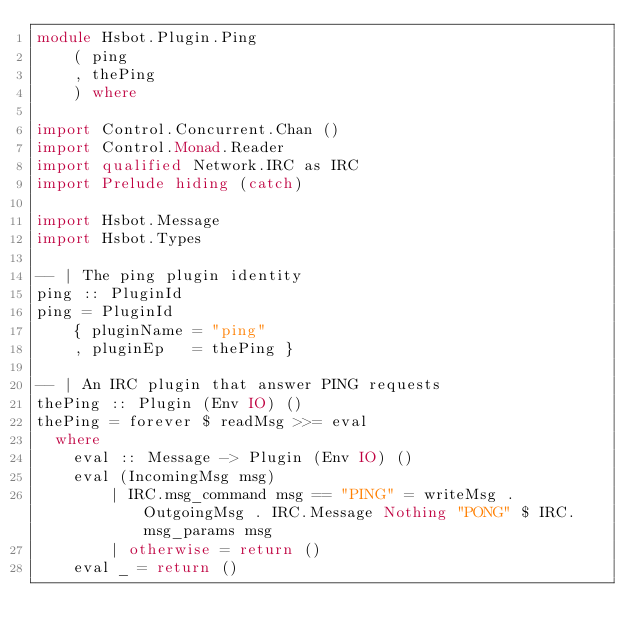Convert code to text. <code><loc_0><loc_0><loc_500><loc_500><_Haskell_>module Hsbot.Plugin.Ping
    ( ping
    , thePing
    ) where

import Control.Concurrent.Chan ()
import Control.Monad.Reader
import qualified Network.IRC as IRC
import Prelude hiding (catch)

import Hsbot.Message
import Hsbot.Types

-- | The ping plugin identity
ping :: PluginId
ping = PluginId
    { pluginName = "ping"
    , pluginEp   = thePing }

-- | An IRC plugin that answer PING requests
thePing :: Plugin (Env IO) ()
thePing = forever $ readMsg >>= eval
  where
    eval :: Message -> Plugin (Env IO) ()
    eval (IncomingMsg msg)
        | IRC.msg_command msg == "PING" = writeMsg . OutgoingMsg . IRC.Message Nothing "PONG" $ IRC.msg_params msg
        | otherwise = return ()
    eval _ = return ()

</code> 